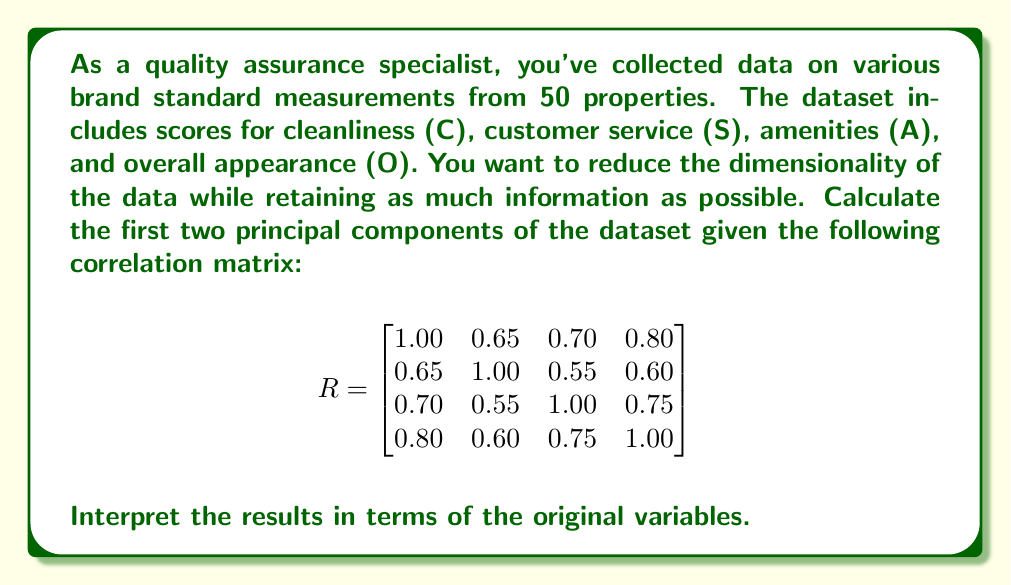Show me your answer to this math problem. To calculate the principal components, we need to follow these steps:

1. Find the eigenvalues and eigenvectors of the correlation matrix.
2. Sort the eigenvalues in descending order and select the corresponding eigenvectors.
3. Normalize the eigenvectors to get the loadings for each principal component.
4. Interpret the results.

Step 1: Find eigenvalues and eigenvectors

We can use a computer algebra system to find the eigenvalues and eigenvectors. The results are:

Eigenvalues: $\lambda_1 = 3.0456$, $\lambda_2 = 0.4544$, $\lambda_3 = 0.2898$, $\lambda_4 = 0.2102$

Eigenvectors (columns):
$$
V = \begin{bmatrix}
-0.5237 & -0.4302 & 0.4685 & 0.5656 \\
-0.4576 & 0.8544 & 0.2392 & -0.0631 \\
-0.4981 & -0.2205 & -0.8391 & -0.0754 \\
-0.5187 & -0.1942 & 0.1054 & -0.8187
\end{bmatrix}
$$

Step 2: Sort eigenvalues and select eigenvectors

The eigenvalues are already in descending order. We'll select the first two eigenvectors corresponding to the two largest eigenvalues.

Step 3: Normalize eigenvectors to get loadings

The loadings are the normalized eigenvectors. For the first two principal components:

PC1: $[-0.5237, -0.4576, -0.4981, -0.5187]$
PC2: $[-0.4302, 0.8544, -0.2205, -0.1942]$

Step 4: Interpret the results

PC1 explains $3.0456 / 4 = 76.14\%$ of the total variance.
PC2 explains $0.4544 / 4 = 11.36\%$ of the total variance.

Together, they explain $87.50\%$ of the total variance.

Interpreting PC1:
All variables have similar negative loadings, indicating that PC1 represents an overall quality score. Higher values of PC1 correspond to lower scores across all measures.

Interpreting PC2:
Customer service (S) has a large positive loading, while the other variables have smaller negative loadings. This suggests that PC2 contrasts customer service with the other measures, possibly representing a trade-off between service and other aspects of brand standards.
Answer: The first two principal components are:

PC1: $[-0.5237, -0.4576, -0.4981, -0.5187]$
PC2: $[-0.4302, 0.8544, -0.2205, -0.1942]$

PC1 explains 76.14% of the total variance and represents an overall quality score.
PC2 explains 11.36% of the total variance and contrasts customer service with other measures.

Together, they explain 87.50% of the total variance in the brand standard measurements. 